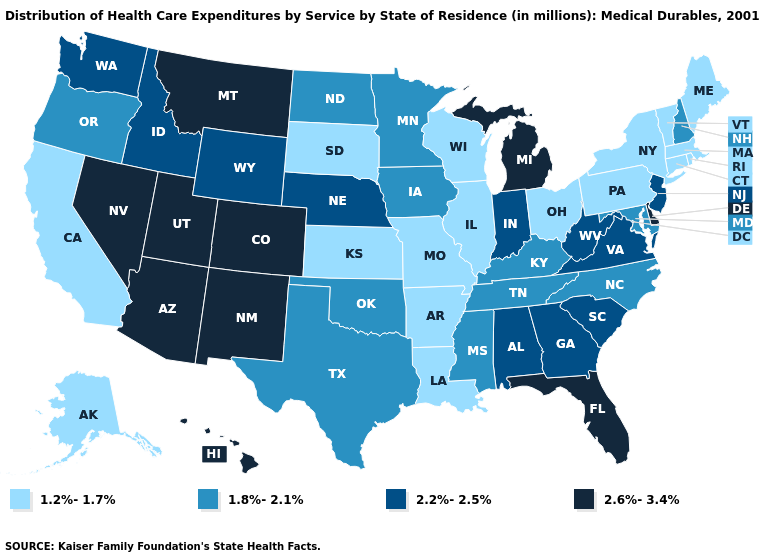Does Montana have the highest value in the USA?
Short answer required. Yes. What is the lowest value in the USA?
Be succinct. 1.2%-1.7%. What is the highest value in the USA?
Write a very short answer. 2.6%-3.4%. Name the states that have a value in the range 1.8%-2.1%?
Short answer required. Iowa, Kentucky, Maryland, Minnesota, Mississippi, New Hampshire, North Carolina, North Dakota, Oklahoma, Oregon, Tennessee, Texas. Does the map have missing data?
Write a very short answer. No. Does Colorado have the lowest value in the USA?
Quick response, please. No. Does the map have missing data?
Quick response, please. No. Does South Dakota have a lower value than Washington?
Answer briefly. Yes. Among the states that border Idaho , which have the lowest value?
Keep it brief. Oregon. Does the first symbol in the legend represent the smallest category?
Concise answer only. Yes. Which states have the highest value in the USA?
Answer briefly. Arizona, Colorado, Delaware, Florida, Hawaii, Michigan, Montana, Nevada, New Mexico, Utah. Name the states that have a value in the range 1.8%-2.1%?
Answer briefly. Iowa, Kentucky, Maryland, Minnesota, Mississippi, New Hampshire, North Carolina, North Dakota, Oklahoma, Oregon, Tennessee, Texas. What is the value of Wyoming?
Quick response, please. 2.2%-2.5%. Does the first symbol in the legend represent the smallest category?
Write a very short answer. Yes. Does Indiana have the same value as California?
Give a very brief answer. No. 